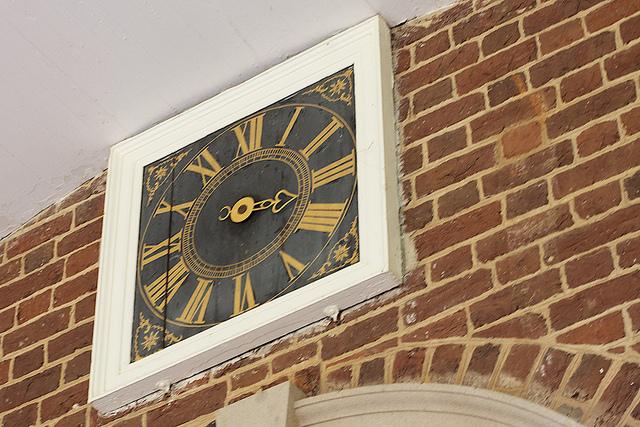Is that time right?
Keep it brief. No. Is this clock part of a clock tower?
Short answer required. No. Is the clock round?
Answer briefly. No. What texture is on the wall?
Be succinct. Brick. What time does the clock show?
Quick response, please. 3:15. What color is the clock?
Give a very brief answer. Black. 